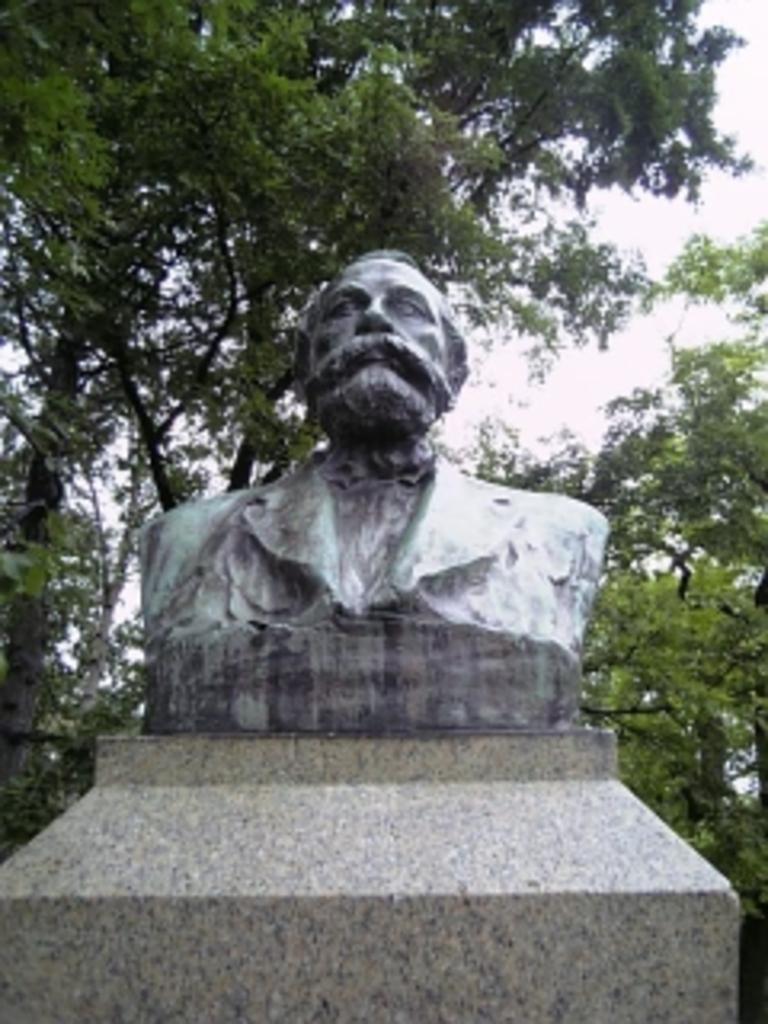In one or two sentences, can you explain what this image depicts? In the image there is a statue of a man and behind the statue there are trees. 